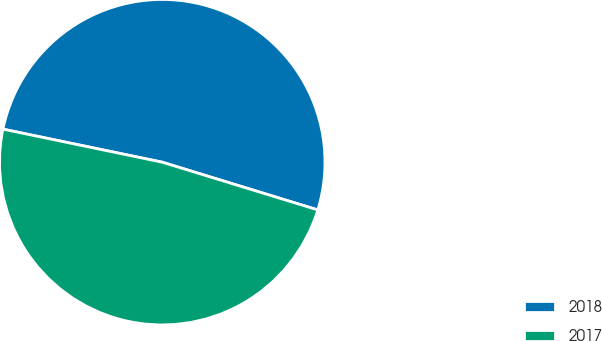Convert chart to OTSL. <chart><loc_0><loc_0><loc_500><loc_500><pie_chart><fcel>2018<fcel>2017<nl><fcel>51.48%<fcel>48.52%<nl></chart> 